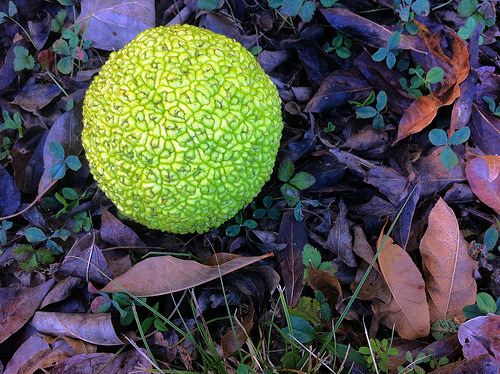<image>
Can you confirm if the leaf is under the clover? Yes. The leaf is positioned underneath the clover, with the clover above it in the vertical space. 